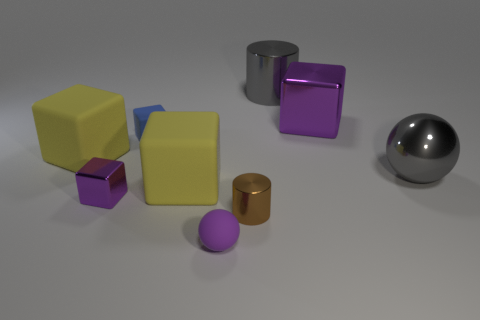Can you describe the colors and shapes of the objects in the image? Sure, the image features objects of various shapes including cubes, cylinders, and a sphere. The colors of these objects consist of yellow, purple, gray, orange, and metallic shades. The cubes come in yellow and purple, there's a purple cylinder, a gray cylinder, and an orange cylinder, while the sphere is shiny and metallic.  Which object is the largest and which is the smallest? The largest object in the image appears to be the yellow cube on the left, due to its visible size in comparison to other objects. The smallest object is the purple cube located in the center of the image, just in front of the larger cubes. 